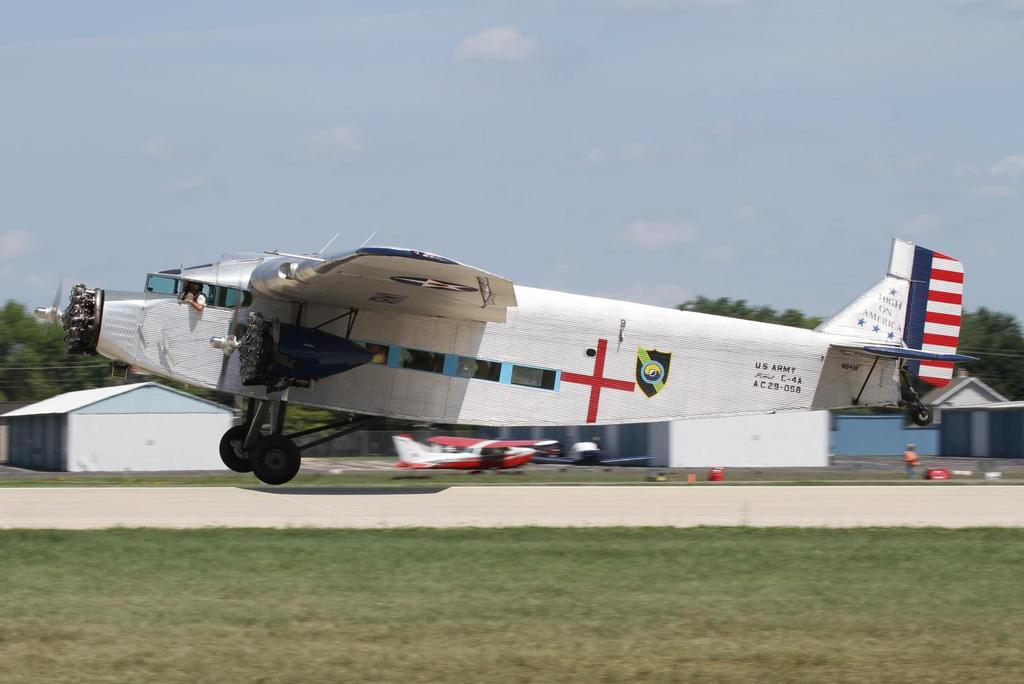<image>
Write a terse but informative summary of the picture. An old turboprop airplane with the words Fight on America takes off from the runway 